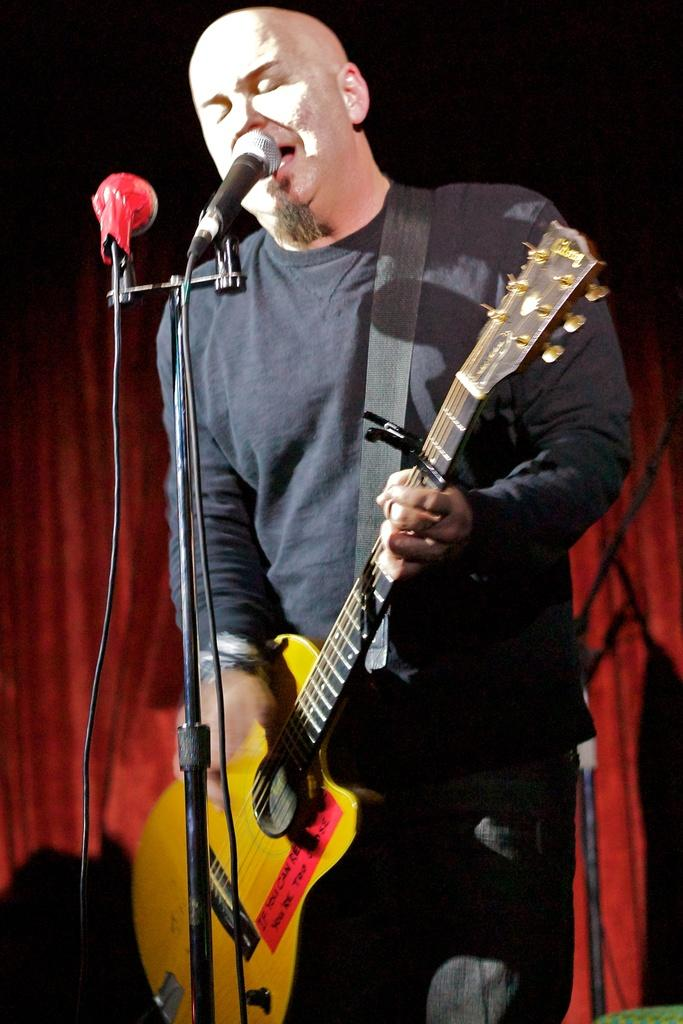Who is the main subject in the image? There is a man in the image. What is the man holding in the image? The man is holding a guitar. What object is in front of the man? The man is in front of a microphone. What hobbies does the man have in the afternoon? The provided facts do not mention the man's hobbies or the time of day, so we cannot determine his hobbies or the time of day from the image. 